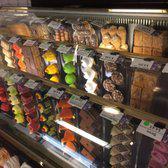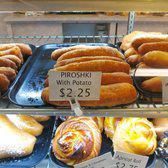The first image is the image on the left, the second image is the image on the right. Assess this claim about the two images: "Windows can be seen in the image on the left.". Correct or not? Answer yes or no. No. 